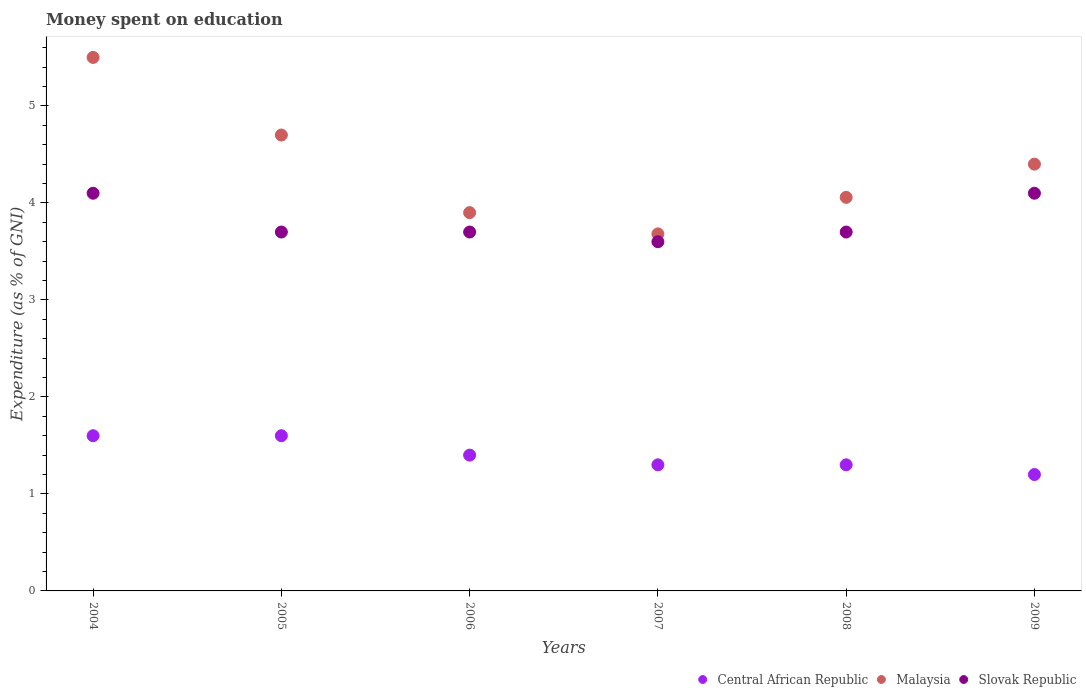Is the number of dotlines equal to the number of legend labels?
Make the answer very short. Yes. Across all years, what is the maximum amount of money spent on education in Slovak Republic?
Ensure brevity in your answer.  4.1. Across all years, what is the minimum amount of money spent on education in Malaysia?
Provide a succinct answer. 3.68. In which year was the amount of money spent on education in Malaysia maximum?
Give a very brief answer. 2004. What is the total amount of money spent on education in Central African Republic in the graph?
Provide a succinct answer. 8.4. What is the difference between the amount of money spent on education in Slovak Republic in 2005 and that in 2008?
Give a very brief answer. 0. What is the difference between the amount of money spent on education in Central African Republic in 2004 and the amount of money spent on education in Malaysia in 2007?
Give a very brief answer. -2.08. What is the average amount of money spent on education in Malaysia per year?
Make the answer very short. 4.37. In the year 2009, what is the difference between the amount of money spent on education in Central African Republic and amount of money spent on education in Malaysia?
Your answer should be very brief. -3.2. What is the ratio of the amount of money spent on education in Malaysia in 2005 to that in 2009?
Give a very brief answer. 1.07. What is the difference between the highest and the second highest amount of money spent on education in Malaysia?
Keep it short and to the point. 0.8. What is the difference between the highest and the lowest amount of money spent on education in Central African Republic?
Keep it short and to the point. 0.4. Is the sum of the amount of money spent on education in Central African Republic in 2006 and 2009 greater than the maximum amount of money spent on education in Malaysia across all years?
Your answer should be very brief. No. Is it the case that in every year, the sum of the amount of money spent on education in Central African Republic and amount of money spent on education in Malaysia  is greater than the amount of money spent on education in Slovak Republic?
Your answer should be very brief. Yes. Does the amount of money spent on education in Malaysia monotonically increase over the years?
Your response must be concise. No. Is the amount of money spent on education in Slovak Republic strictly greater than the amount of money spent on education in Malaysia over the years?
Your response must be concise. No. How many dotlines are there?
Give a very brief answer. 3. How many years are there in the graph?
Provide a short and direct response. 6. What is the difference between two consecutive major ticks on the Y-axis?
Your answer should be compact. 1. Are the values on the major ticks of Y-axis written in scientific E-notation?
Your response must be concise. No. Does the graph contain grids?
Make the answer very short. No. Where does the legend appear in the graph?
Ensure brevity in your answer.  Bottom right. How many legend labels are there?
Make the answer very short. 3. How are the legend labels stacked?
Ensure brevity in your answer.  Horizontal. What is the title of the graph?
Your response must be concise. Money spent on education. What is the label or title of the Y-axis?
Offer a very short reply. Expenditure (as % of GNI). What is the Expenditure (as % of GNI) in Central African Republic in 2005?
Your answer should be very brief. 1.6. What is the Expenditure (as % of GNI) in Malaysia in 2005?
Give a very brief answer. 4.7. What is the Expenditure (as % of GNI) of Central African Republic in 2006?
Your response must be concise. 1.4. What is the Expenditure (as % of GNI) of Slovak Republic in 2006?
Make the answer very short. 3.7. What is the Expenditure (as % of GNI) of Malaysia in 2007?
Ensure brevity in your answer.  3.68. What is the Expenditure (as % of GNI) in Slovak Republic in 2007?
Offer a terse response. 3.6. What is the Expenditure (as % of GNI) of Malaysia in 2008?
Offer a very short reply. 4.06. What is the Expenditure (as % of GNI) of Slovak Republic in 2008?
Provide a short and direct response. 3.7. What is the Expenditure (as % of GNI) of Slovak Republic in 2009?
Ensure brevity in your answer.  4.1. Across all years, what is the maximum Expenditure (as % of GNI) of Malaysia?
Your answer should be compact. 5.5. Across all years, what is the maximum Expenditure (as % of GNI) in Slovak Republic?
Offer a very short reply. 4.1. Across all years, what is the minimum Expenditure (as % of GNI) of Malaysia?
Keep it short and to the point. 3.68. Across all years, what is the minimum Expenditure (as % of GNI) of Slovak Republic?
Give a very brief answer. 3.6. What is the total Expenditure (as % of GNI) in Malaysia in the graph?
Provide a succinct answer. 26.24. What is the total Expenditure (as % of GNI) of Slovak Republic in the graph?
Your answer should be very brief. 22.9. What is the difference between the Expenditure (as % of GNI) in Central African Republic in 2004 and that in 2006?
Provide a short and direct response. 0.2. What is the difference between the Expenditure (as % of GNI) of Central African Republic in 2004 and that in 2007?
Your answer should be very brief. 0.3. What is the difference between the Expenditure (as % of GNI) of Malaysia in 2004 and that in 2007?
Ensure brevity in your answer.  1.82. What is the difference between the Expenditure (as % of GNI) in Central African Republic in 2004 and that in 2008?
Your answer should be compact. 0.3. What is the difference between the Expenditure (as % of GNI) in Malaysia in 2004 and that in 2008?
Provide a succinct answer. 1.44. What is the difference between the Expenditure (as % of GNI) of Slovak Republic in 2005 and that in 2006?
Give a very brief answer. 0. What is the difference between the Expenditure (as % of GNI) of Central African Republic in 2005 and that in 2007?
Offer a terse response. 0.3. What is the difference between the Expenditure (as % of GNI) in Malaysia in 2005 and that in 2007?
Give a very brief answer. 1.02. What is the difference between the Expenditure (as % of GNI) of Slovak Republic in 2005 and that in 2007?
Offer a terse response. 0.1. What is the difference between the Expenditure (as % of GNI) in Central African Republic in 2005 and that in 2008?
Give a very brief answer. 0.3. What is the difference between the Expenditure (as % of GNI) in Malaysia in 2005 and that in 2008?
Offer a terse response. 0.64. What is the difference between the Expenditure (as % of GNI) of Slovak Republic in 2005 and that in 2008?
Keep it short and to the point. 0. What is the difference between the Expenditure (as % of GNI) in Central African Republic in 2005 and that in 2009?
Provide a succinct answer. 0.4. What is the difference between the Expenditure (as % of GNI) in Slovak Republic in 2005 and that in 2009?
Offer a terse response. -0.4. What is the difference between the Expenditure (as % of GNI) of Malaysia in 2006 and that in 2007?
Provide a succinct answer. 0.22. What is the difference between the Expenditure (as % of GNI) of Slovak Republic in 2006 and that in 2007?
Provide a short and direct response. 0.1. What is the difference between the Expenditure (as % of GNI) of Malaysia in 2006 and that in 2008?
Provide a succinct answer. -0.16. What is the difference between the Expenditure (as % of GNI) in Central African Republic in 2006 and that in 2009?
Give a very brief answer. 0.2. What is the difference between the Expenditure (as % of GNI) of Malaysia in 2006 and that in 2009?
Offer a very short reply. -0.5. What is the difference between the Expenditure (as % of GNI) of Slovak Republic in 2006 and that in 2009?
Keep it short and to the point. -0.4. What is the difference between the Expenditure (as % of GNI) of Malaysia in 2007 and that in 2008?
Ensure brevity in your answer.  -0.38. What is the difference between the Expenditure (as % of GNI) of Malaysia in 2007 and that in 2009?
Offer a very short reply. -0.72. What is the difference between the Expenditure (as % of GNI) in Slovak Republic in 2007 and that in 2009?
Keep it short and to the point. -0.5. What is the difference between the Expenditure (as % of GNI) of Malaysia in 2008 and that in 2009?
Provide a succinct answer. -0.34. What is the difference between the Expenditure (as % of GNI) in Central African Republic in 2004 and the Expenditure (as % of GNI) in Malaysia in 2005?
Provide a succinct answer. -3.1. What is the difference between the Expenditure (as % of GNI) of Malaysia in 2004 and the Expenditure (as % of GNI) of Slovak Republic in 2006?
Offer a very short reply. 1.8. What is the difference between the Expenditure (as % of GNI) of Central African Republic in 2004 and the Expenditure (as % of GNI) of Malaysia in 2007?
Keep it short and to the point. -2.08. What is the difference between the Expenditure (as % of GNI) of Malaysia in 2004 and the Expenditure (as % of GNI) of Slovak Republic in 2007?
Provide a short and direct response. 1.9. What is the difference between the Expenditure (as % of GNI) of Central African Republic in 2004 and the Expenditure (as % of GNI) of Malaysia in 2008?
Offer a very short reply. -2.46. What is the difference between the Expenditure (as % of GNI) of Malaysia in 2004 and the Expenditure (as % of GNI) of Slovak Republic in 2008?
Provide a short and direct response. 1.8. What is the difference between the Expenditure (as % of GNI) of Central African Republic in 2004 and the Expenditure (as % of GNI) of Malaysia in 2009?
Ensure brevity in your answer.  -2.8. What is the difference between the Expenditure (as % of GNI) of Malaysia in 2004 and the Expenditure (as % of GNI) of Slovak Republic in 2009?
Offer a terse response. 1.4. What is the difference between the Expenditure (as % of GNI) of Central African Republic in 2005 and the Expenditure (as % of GNI) of Slovak Republic in 2006?
Keep it short and to the point. -2.1. What is the difference between the Expenditure (as % of GNI) of Central African Republic in 2005 and the Expenditure (as % of GNI) of Malaysia in 2007?
Offer a very short reply. -2.08. What is the difference between the Expenditure (as % of GNI) of Central African Republic in 2005 and the Expenditure (as % of GNI) of Slovak Republic in 2007?
Offer a very short reply. -2. What is the difference between the Expenditure (as % of GNI) of Central African Republic in 2005 and the Expenditure (as % of GNI) of Malaysia in 2008?
Offer a very short reply. -2.46. What is the difference between the Expenditure (as % of GNI) of Central African Republic in 2005 and the Expenditure (as % of GNI) of Slovak Republic in 2008?
Your answer should be very brief. -2.1. What is the difference between the Expenditure (as % of GNI) in Malaysia in 2005 and the Expenditure (as % of GNI) in Slovak Republic in 2008?
Offer a very short reply. 1. What is the difference between the Expenditure (as % of GNI) in Central African Republic in 2005 and the Expenditure (as % of GNI) in Malaysia in 2009?
Your response must be concise. -2.8. What is the difference between the Expenditure (as % of GNI) of Central African Republic in 2006 and the Expenditure (as % of GNI) of Malaysia in 2007?
Ensure brevity in your answer.  -2.28. What is the difference between the Expenditure (as % of GNI) of Central African Republic in 2006 and the Expenditure (as % of GNI) of Slovak Republic in 2007?
Keep it short and to the point. -2.2. What is the difference between the Expenditure (as % of GNI) in Central African Republic in 2006 and the Expenditure (as % of GNI) in Malaysia in 2008?
Provide a succinct answer. -2.66. What is the difference between the Expenditure (as % of GNI) of Central African Republic in 2006 and the Expenditure (as % of GNI) of Slovak Republic in 2009?
Make the answer very short. -2.7. What is the difference between the Expenditure (as % of GNI) of Malaysia in 2006 and the Expenditure (as % of GNI) of Slovak Republic in 2009?
Offer a terse response. -0.2. What is the difference between the Expenditure (as % of GNI) of Central African Republic in 2007 and the Expenditure (as % of GNI) of Malaysia in 2008?
Keep it short and to the point. -2.76. What is the difference between the Expenditure (as % of GNI) in Malaysia in 2007 and the Expenditure (as % of GNI) in Slovak Republic in 2008?
Make the answer very short. -0.02. What is the difference between the Expenditure (as % of GNI) in Malaysia in 2007 and the Expenditure (as % of GNI) in Slovak Republic in 2009?
Give a very brief answer. -0.42. What is the difference between the Expenditure (as % of GNI) of Malaysia in 2008 and the Expenditure (as % of GNI) of Slovak Republic in 2009?
Offer a terse response. -0.04. What is the average Expenditure (as % of GNI) in Central African Republic per year?
Provide a short and direct response. 1.4. What is the average Expenditure (as % of GNI) of Malaysia per year?
Your answer should be compact. 4.37. What is the average Expenditure (as % of GNI) of Slovak Republic per year?
Your answer should be compact. 3.82. In the year 2004, what is the difference between the Expenditure (as % of GNI) of Central African Republic and Expenditure (as % of GNI) of Malaysia?
Provide a succinct answer. -3.9. In the year 2004, what is the difference between the Expenditure (as % of GNI) of Central African Republic and Expenditure (as % of GNI) of Slovak Republic?
Your answer should be very brief. -2.5. In the year 2004, what is the difference between the Expenditure (as % of GNI) of Malaysia and Expenditure (as % of GNI) of Slovak Republic?
Make the answer very short. 1.4. In the year 2005, what is the difference between the Expenditure (as % of GNI) in Central African Republic and Expenditure (as % of GNI) in Malaysia?
Keep it short and to the point. -3.1. In the year 2006, what is the difference between the Expenditure (as % of GNI) in Malaysia and Expenditure (as % of GNI) in Slovak Republic?
Give a very brief answer. 0.2. In the year 2007, what is the difference between the Expenditure (as % of GNI) in Central African Republic and Expenditure (as % of GNI) in Malaysia?
Offer a very short reply. -2.38. In the year 2007, what is the difference between the Expenditure (as % of GNI) in Malaysia and Expenditure (as % of GNI) in Slovak Republic?
Give a very brief answer. 0.08. In the year 2008, what is the difference between the Expenditure (as % of GNI) of Central African Republic and Expenditure (as % of GNI) of Malaysia?
Provide a short and direct response. -2.76. In the year 2008, what is the difference between the Expenditure (as % of GNI) in Malaysia and Expenditure (as % of GNI) in Slovak Republic?
Offer a terse response. 0.36. In the year 2009, what is the difference between the Expenditure (as % of GNI) of Central African Republic and Expenditure (as % of GNI) of Malaysia?
Offer a very short reply. -3.2. What is the ratio of the Expenditure (as % of GNI) in Central African Republic in 2004 to that in 2005?
Your answer should be compact. 1. What is the ratio of the Expenditure (as % of GNI) of Malaysia in 2004 to that in 2005?
Your response must be concise. 1.17. What is the ratio of the Expenditure (as % of GNI) in Slovak Republic in 2004 to that in 2005?
Provide a succinct answer. 1.11. What is the ratio of the Expenditure (as % of GNI) of Malaysia in 2004 to that in 2006?
Provide a succinct answer. 1.41. What is the ratio of the Expenditure (as % of GNI) of Slovak Republic in 2004 to that in 2006?
Give a very brief answer. 1.11. What is the ratio of the Expenditure (as % of GNI) in Central African Republic in 2004 to that in 2007?
Provide a short and direct response. 1.23. What is the ratio of the Expenditure (as % of GNI) in Malaysia in 2004 to that in 2007?
Provide a succinct answer. 1.49. What is the ratio of the Expenditure (as % of GNI) of Slovak Republic in 2004 to that in 2007?
Your answer should be compact. 1.14. What is the ratio of the Expenditure (as % of GNI) in Central African Republic in 2004 to that in 2008?
Give a very brief answer. 1.23. What is the ratio of the Expenditure (as % of GNI) in Malaysia in 2004 to that in 2008?
Provide a succinct answer. 1.36. What is the ratio of the Expenditure (as % of GNI) in Slovak Republic in 2004 to that in 2008?
Your answer should be compact. 1.11. What is the ratio of the Expenditure (as % of GNI) of Malaysia in 2004 to that in 2009?
Ensure brevity in your answer.  1.25. What is the ratio of the Expenditure (as % of GNI) of Malaysia in 2005 to that in 2006?
Make the answer very short. 1.21. What is the ratio of the Expenditure (as % of GNI) of Slovak Republic in 2005 to that in 2006?
Keep it short and to the point. 1. What is the ratio of the Expenditure (as % of GNI) of Central African Republic in 2005 to that in 2007?
Your answer should be very brief. 1.23. What is the ratio of the Expenditure (as % of GNI) in Malaysia in 2005 to that in 2007?
Keep it short and to the point. 1.28. What is the ratio of the Expenditure (as % of GNI) in Slovak Republic in 2005 to that in 2007?
Make the answer very short. 1.03. What is the ratio of the Expenditure (as % of GNI) in Central African Republic in 2005 to that in 2008?
Provide a short and direct response. 1.23. What is the ratio of the Expenditure (as % of GNI) of Malaysia in 2005 to that in 2008?
Offer a very short reply. 1.16. What is the ratio of the Expenditure (as % of GNI) of Slovak Republic in 2005 to that in 2008?
Give a very brief answer. 1. What is the ratio of the Expenditure (as % of GNI) in Central African Republic in 2005 to that in 2009?
Offer a very short reply. 1.33. What is the ratio of the Expenditure (as % of GNI) of Malaysia in 2005 to that in 2009?
Your answer should be compact. 1.07. What is the ratio of the Expenditure (as % of GNI) in Slovak Republic in 2005 to that in 2009?
Your answer should be compact. 0.9. What is the ratio of the Expenditure (as % of GNI) in Malaysia in 2006 to that in 2007?
Give a very brief answer. 1.06. What is the ratio of the Expenditure (as % of GNI) of Slovak Republic in 2006 to that in 2007?
Make the answer very short. 1.03. What is the ratio of the Expenditure (as % of GNI) of Central African Republic in 2006 to that in 2008?
Give a very brief answer. 1.08. What is the ratio of the Expenditure (as % of GNI) in Malaysia in 2006 to that in 2008?
Provide a succinct answer. 0.96. What is the ratio of the Expenditure (as % of GNI) of Slovak Republic in 2006 to that in 2008?
Make the answer very short. 1. What is the ratio of the Expenditure (as % of GNI) in Malaysia in 2006 to that in 2009?
Provide a short and direct response. 0.89. What is the ratio of the Expenditure (as % of GNI) in Slovak Republic in 2006 to that in 2009?
Keep it short and to the point. 0.9. What is the ratio of the Expenditure (as % of GNI) in Malaysia in 2007 to that in 2008?
Your answer should be compact. 0.91. What is the ratio of the Expenditure (as % of GNI) in Malaysia in 2007 to that in 2009?
Your response must be concise. 0.84. What is the ratio of the Expenditure (as % of GNI) in Slovak Republic in 2007 to that in 2009?
Provide a short and direct response. 0.88. What is the ratio of the Expenditure (as % of GNI) in Central African Republic in 2008 to that in 2009?
Your answer should be compact. 1.08. What is the ratio of the Expenditure (as % of GNI) of Malaysia in 2008 to that in 2009?
Offer a terse response. 0.92. What is the ratio of the Expenditure (as % of GNI) of Slovak Republic in 2008 to that in 2009?
Ensure brevity in your answer.  0.9. What is the difference between the highest and the second highest Expenditure (as % of GNI) in Central African Republic?
Your response must be concise. 0. What is the difference between the highest and the second highest Expenditure (as % of GNI) in Malaysia?
Provide a short and direct response. 0.8. What is the difference between the highest and the lowest Expenditure (as % of GNI) in Malaysia?
Provide a succinct answer. 1.82. 